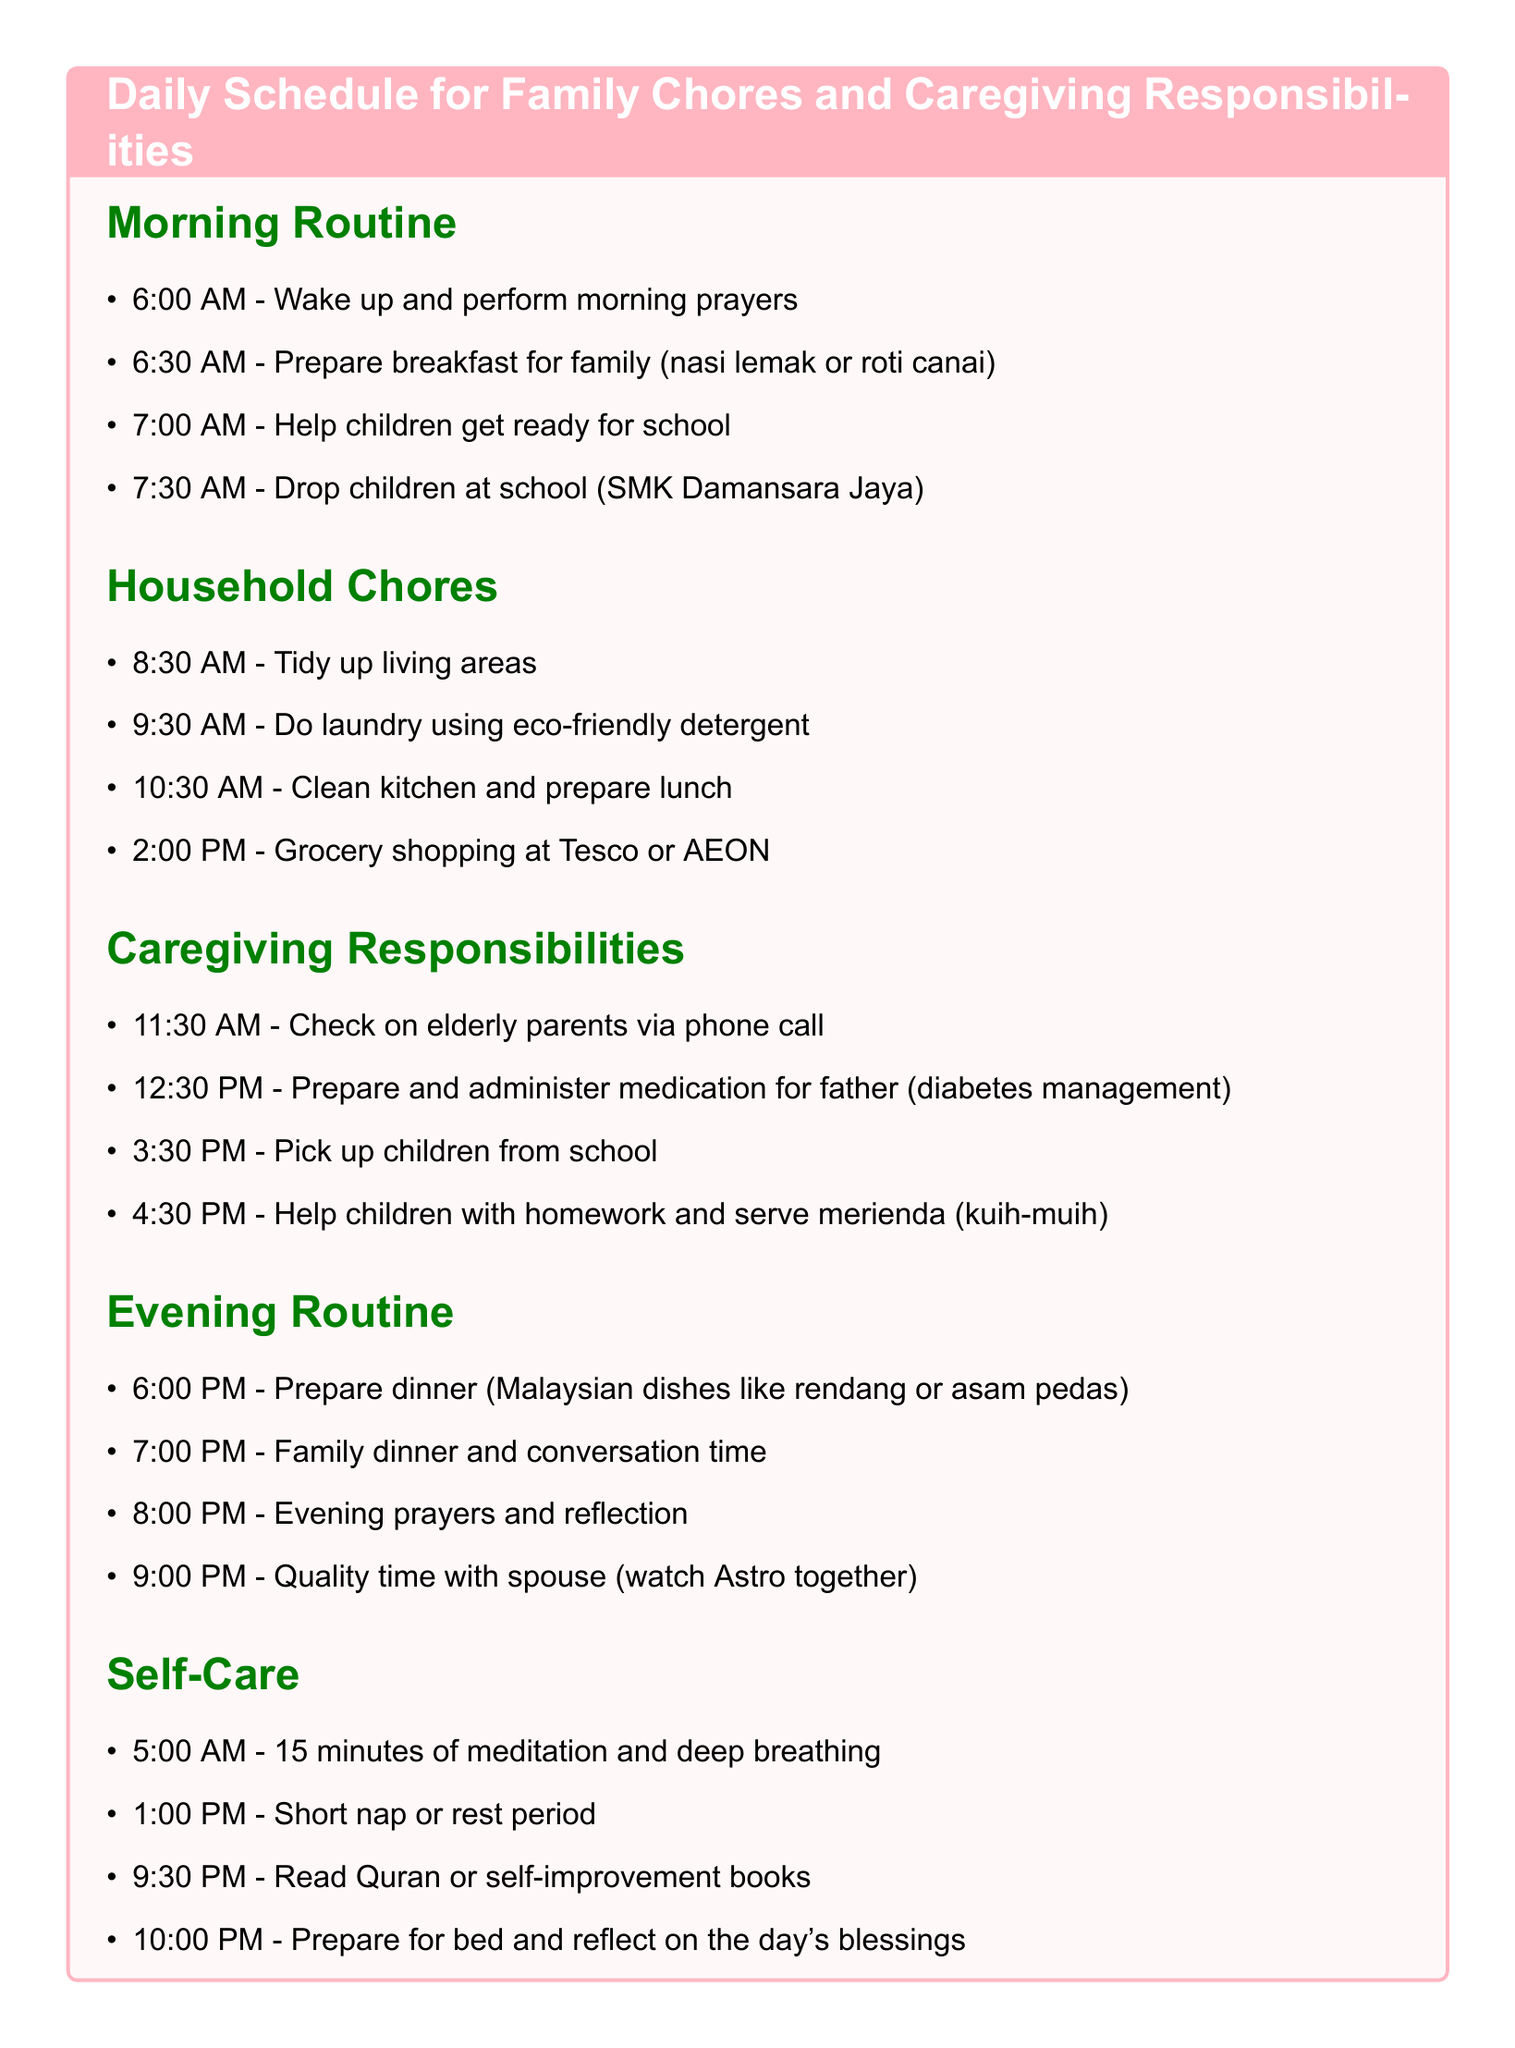What time is breakfast prepared? Breakfast is prepared at 6:30 AM as listed in the morning routine.
Answer: 6:30 AM What tasks are included in the household chores section? The household chores section includes tidying up, doing laundry, cleaning the kitchen, and grocery shopping.
Answer: Tidy up living areas, do laundry using eco-friendly detergent, clean kitchen and prepare lunch, grocery shopping at Tesco or AEON What is administered to the father at 12:30 PM? At 12:30 PM, medication for diabetes management is prepared and administered to the father.
Answer: Medication for father (diabetes management) What time does the evening routine begin? The evening routine begins at 6:00 PM, starting with dinner preparation.
Answer: 6:00 PM How long is the meditation practice in the self-care section? The meditation practice is 15 minutes long, as noted in the self-care section.
Answer: 15 minutes What type of food is prepared for dinner? Dinner includes Malaysian dishes like rendang or asam pedas, as indicated in the evening routine.
Answer: Malaysian dishes like rendang or asam pedas How often does the individual check on elderly parents? The individual checks on elderly parents via phone call once a day at 11:30 AM.
Answer: Once a day At what time is the short rest period scheduled? The short rest period is scheduled for 1:00 PM in the self-care section.
Answer: 1:00 PM 